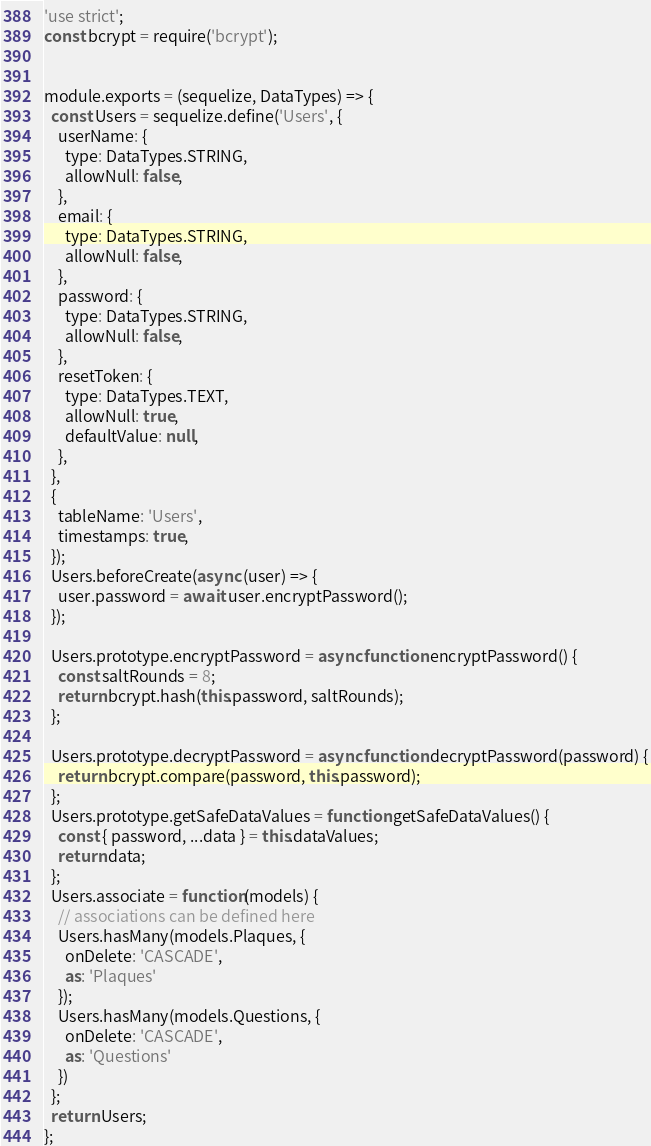Convert code to text. <code><loc_0><loc_0><loc_500><loc_500><_JavaScript_>'use strict';
const bcrypt = require('bcrypt');


module.exports = (sequelize, DataTypes) => {
  const Users = sequelize.define('Users', {
    userName: {
      type: DataTypes.STRING,
      allowNull: false,
    },
    email: {
      type: DataTypes.STRING,
      allowNull: false,
    },
    password: {
      type: DataTypes.STRING,
      allowNull: false,
    },
    resetToken: {
      type: DataTypes.TEXT,
      allowNull: true,
      defaultValue: null,
    },
  },
  {
    tableName: 'Users',
    timestamps: true,
  });
  Users.beforeCreate(async (user) => {
    user.password = await user.encryptPassword();
  });

  Users.prototype.encryptPassword = async function encryptPassword() {
    const saltRounds = 8;
    return bcrypt.hash(this.password, saltRounds);
  };

  Users.prototype.decryptPassword = async function decryptPassword(password) {
    return bcrypt.compare(password, this.password);
  };
  Users.prototype.getSafeDataValues = function getSafeDataValues() {
    const { password, ...data } = this.dataValues;
    return data;
  };
  Users.associate = function(models) {
    // associations can be defined here
    Users.hasMany(models.Plaques, {
      onDelete: 'CASCADE',
      as: 'Plaques'
    });
    Users.hasMany(models.Questions, {
      onDelete: 'CASCADE',
      as: 'Questions'
    })
  };
  return Users;
};</code> 